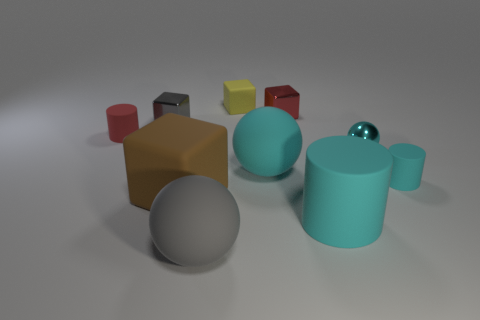How would you describe the overall arrangement of the objects in the image? The objects are arranged in an almost circular pattern around the center of the image, suggesting perhaps some form of intentional organization. The various shapes and colors create a visually interesting composition, placed with ample space between them on a neutral surface, adding to the sense of order and balance in the scene. 